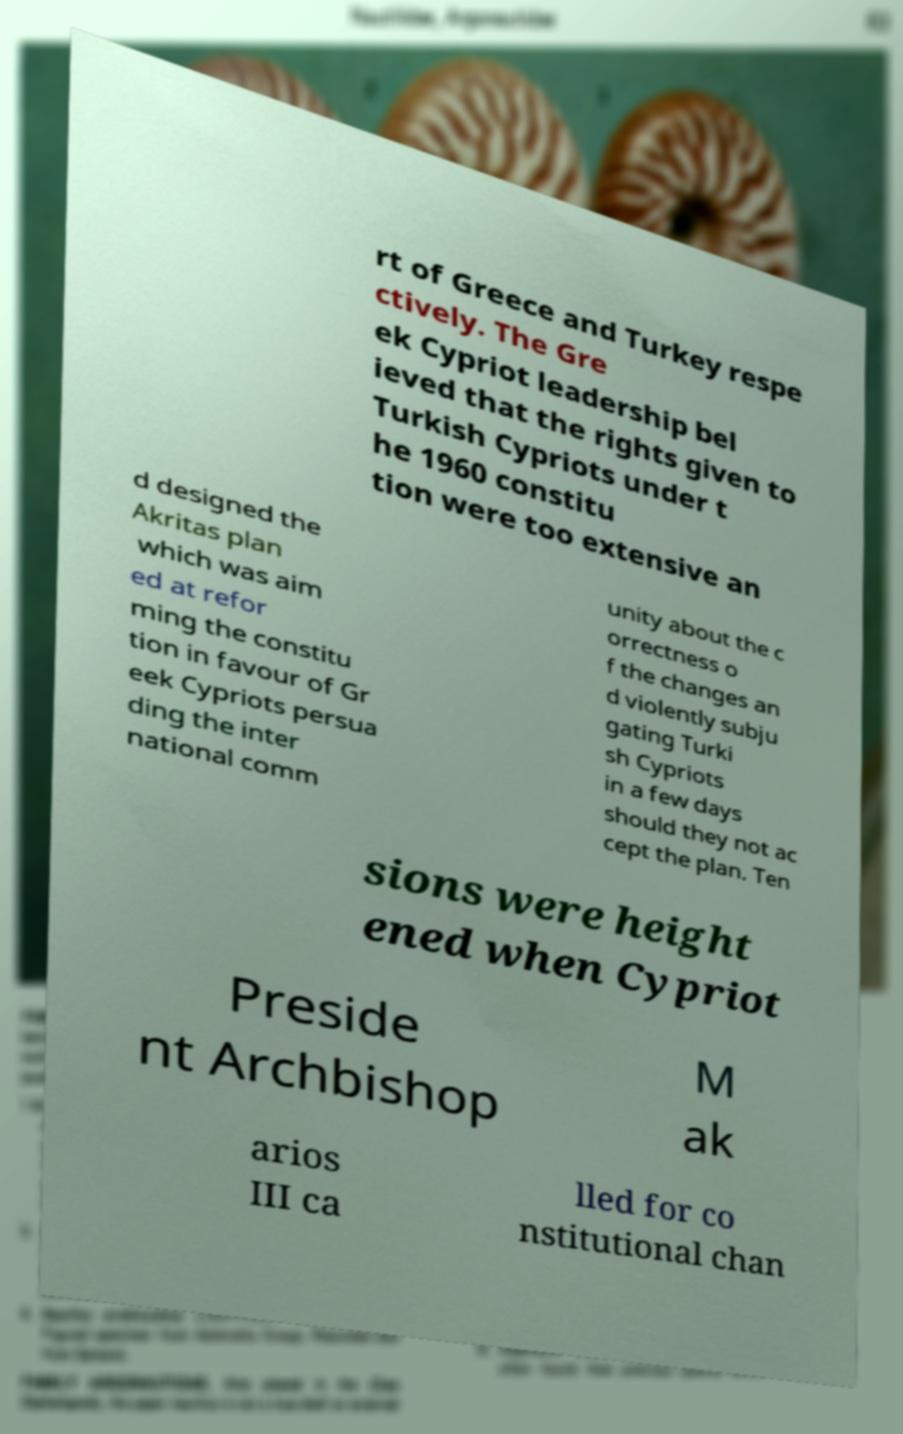I need the written content from this picture converted into text. Can you do that? rt of Greece and Turkey respe ctively. The Gre ek Cypriot leadership bel ieved that the rights given to Turkish Cypriots under t he 1960 constitu tion were too extensive an d designed the Akritas plan which was aim ed at refor ming the constitu tion in favour of Gr eek Cypriots persua ding the inter national comm unity about the c orrectness o f the changes an d violently subju gating Turki sh Cypriots in a few days should they not ac cept the plan. Ten sions were height ened when Cypriot Preside nt Archbishop M ak arios III ca lled for co nstitutional chan 